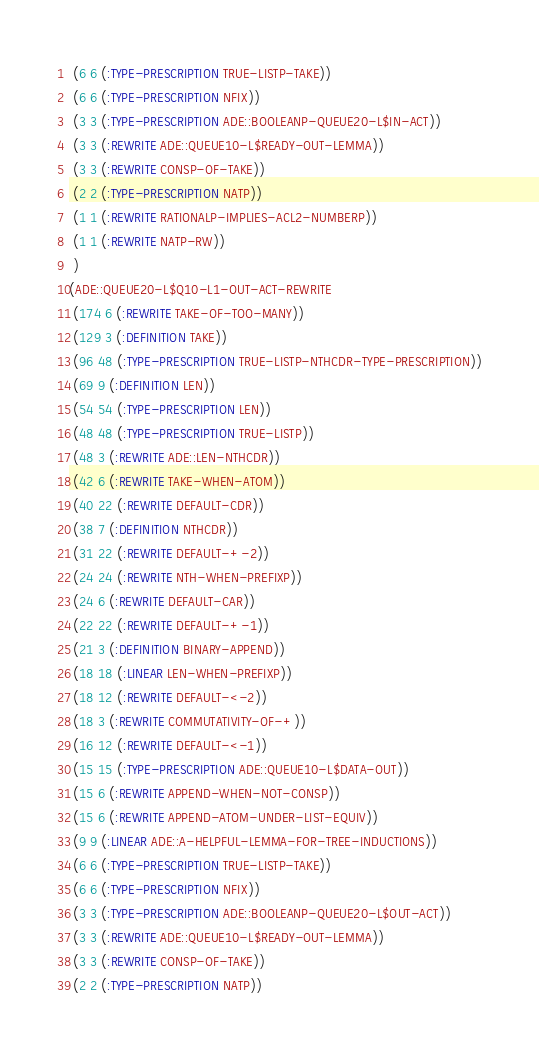<code> <loc_0><loc_0><loc_500><loc_500><_Lisp_> (6 6 (:TYPE-PRESCRIPTION TRUE-LISTP-TAKE))
 (6 6 (:TYPE-PRESCRIPTION NFIX))
 (3 3 (:TYPE-PRESCRIPTION ADE::BOOLEANP-QUEUE20-L$IN-ACT))
 (3 3 (:REWRITE ADE::QUEUE10-L$READY-OUT-LEMMA))
 (3 3 (:REWRITE CONSP-OF-TAKE))
 (2 2 (:TYPE-PRESCRIPTION NATP))
 (1 1 (:REWRITE RATIONALP-IMPLIES-ACL2-NUMBERP))
 (1 1 (:REWRITE NATP-RW))
 )
(ADE::QUEUE20-L$Q10-L1-OUT-ACT-REWRITE
 (174 6 (:REWRITE TAKE-OF-TOO-MANY))
 (129 3 (:DEFINITION TAKE))
 (96 48 (:TYPE-PRESCRIPTION TRUE-LISTP-NTHCDR-TYPE-PRESCRIPTION))
 (69 9 (:DEFINITION LEN))
 (54 54 (:TYPE-PRESCRIPTION LEN))
 (48 48 (:TYPE-PRESCRIPTION TRUE-LISTP))
 (48 3 (:REWRITE ADE::LEN-NTHCDR))
 (42 6 (:REWRITE TAKE-WHEN-ATOM))
 (40 22 (:REWRITE DEFAULT-CDR))
 (38 7 (:DEFINITION NTHCDR))
 (31 22 (:REWRITE DEFAULT-+-2))
 (24 24 (:REWRITE NTH-WHEN-PREFIXP))
 (24 6 (:REWRITE DEFAULT-CAR))
 (22 22 (:REWRITE DEFAULT-+-1))
 (21 3 (:DEFINITION BINARY-APPEND))
 (18 18 (:LINEAR LEN-WHEN-PREFIXP))
 (18 12 (:REWRITE DEFAULT-<-2))
 (18 3 (:REWRITE COMMUTATIVITY-OF-+))
 (16 12 (:REWRITE DEFAULT-<-1))
 (15 15 (:TYPE-PRESCRIPTION ADE::QUEUE10-L$DATA-OUT))
 (15 6 (:REWRITE APPEND-WHEN-NOT-CONSP))
 (15 6 (:REWRITE APPEND-ATOM-UNDER-LIST-EQUIV))
 (9 9 (:LINEAR ADE::A-HELPFUL-LEMMA-FOR-TREE-INDUCTIONS))
 (6 6 (:TYPE-PRESCRIPTION TRUE-LISTP-TAKE))
 (6 6 (:TYPE-PRESCRIPTION NFIX))
 (3 3 (:TYPE-PRESCRIPTION ADE::BOOLEANP-QUEUE20-L$OUT-ACT))
 (3 3 (:REWRITE ADE::QUEUE10-L$READY-OUT-LEMMA))
 (3 3 (:REWRITE CONSP-OF-TAKE))
 (2 2 (:TYPE-PRESCRIPTION NATP))</code> 